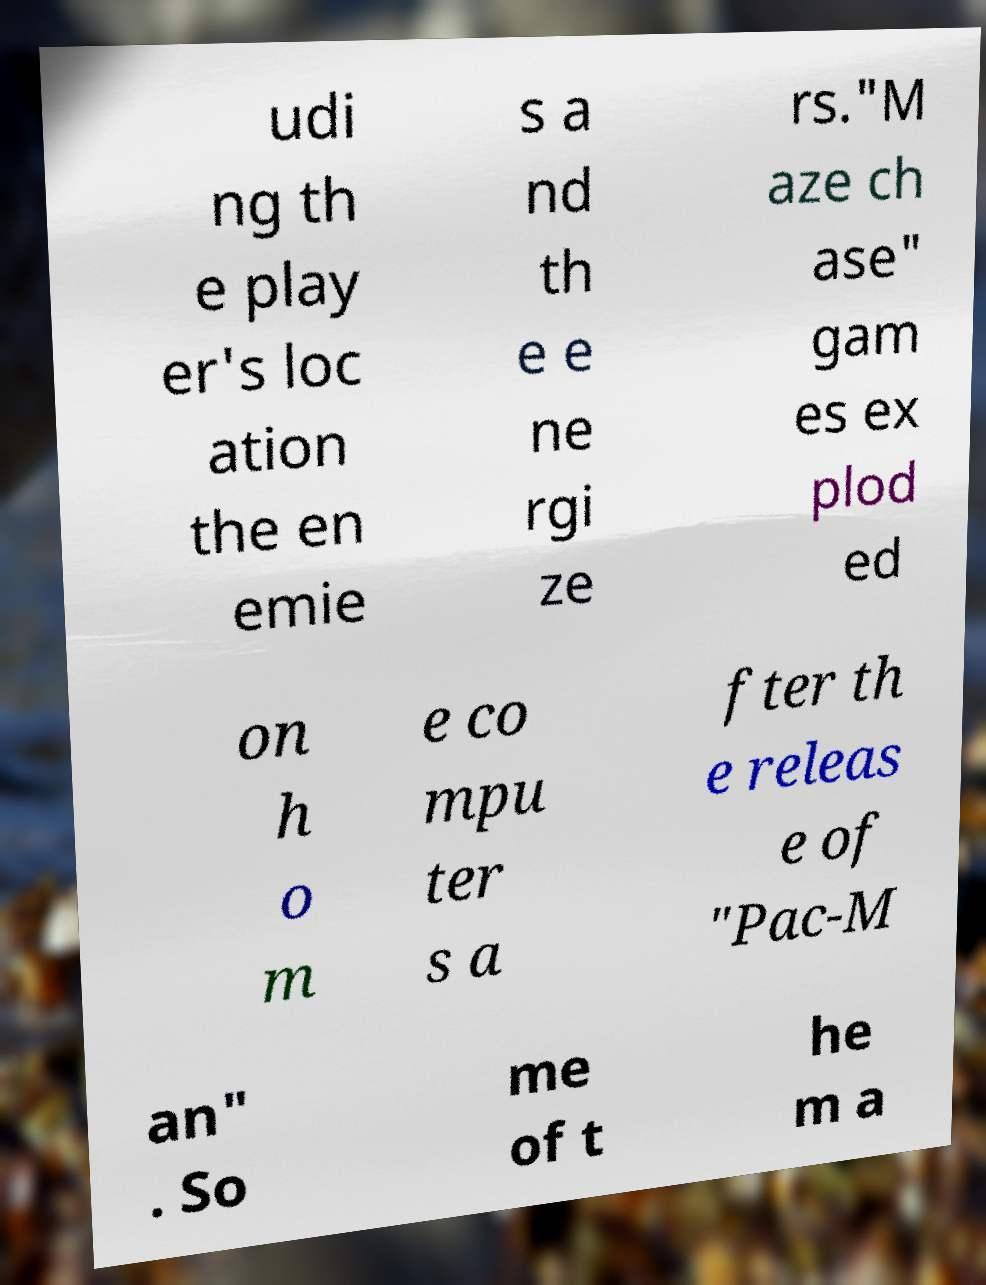Please identify and transcribe the text found in this image. udi ng th e play er's loc ation the en emie s a nd th e e ne rgi ze rs."M aze ch ase" gam es ex plod ed on h o m e co mpu ter s a fter th e releas e of "Pac-M an" . So me of t he m a 